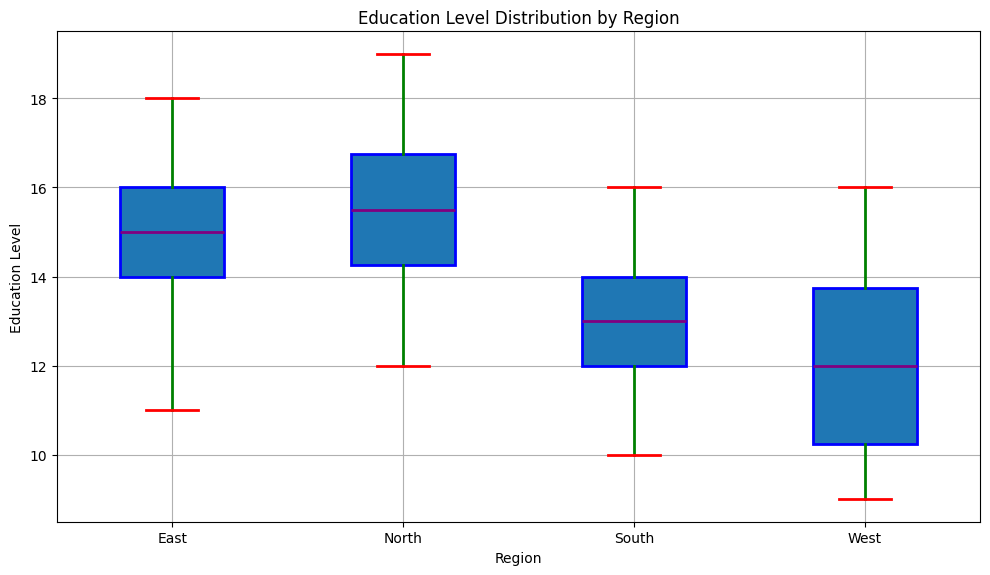What is the median education level in the North region? The median is the middle value in a sorted list. In the North region, the sorted education levels are 12, 13, 14, 15, 15, 16, 16, 17, 18, 19. The median value is between the 5th and 6th data points, which are both 15 and 16. So, the median is (15 + 16) / 2 = 15.5.
Answer: 15.5 Which region has the highest median education level? To determine this, we compare the medians from each region. From the figure, the medians are North: 15.5, South: 13, East: 15.5, West: 12.5. Both North and East have the highest median value of 15.5.
Answer: North and East What is the range of education levels in the South region? The range is the difference between the maximum and minimum values. From the box plot of the South region, the minimum is 10 and the maximum is 16. Therefore, the range is 16 - 10 = 6.
Answer: 6 Which region has the smallest interquartile range (IQR) of education levels? The IQR is the difference between the 75th percentile (Q3) and the 25th percentile (Q1). From the box plots, we visually inspect the length of the boxes (representing the IQR). The South region appears to have the smallest IQR.
Answer: South In which region is the variation in education levels the greatest? Variation refers to the spread of the data. Visually, this can be seen through the length of the whiskers and the spread of the outliers. The West region shows the greatest variation with the widest spread from 9 to 16.
Answer: West What is the maximum education level in the East region? The maximum value is represented by the top whisker or the highest outlier point. In the East region, the maximum education level is 18.
Answer: 18 Compare the median education levels between the South and the West regions. The median is found at the line inside the box. The South region has a median of 13, and the West region has a median of 12.5, so the South's median is higher.
Answer: South is higher How does the median education level in the North compare to the median in the East? Both the North and East regions have the same median education level, as indicated by the lines inside the boxes being at the same level, which is 15.5.
Answer: They are equal Which region has the most symmetric distribution of education levels? Symmetry can be assessed by the positions of the median line within the box and the lengths of the whiskers. The North region appears the most symmetric as the median is centrally located within the box, and the whiskers are of similar length.
Answer: North What is the interquartile range (IQR) of the East region? The IQR is calculated as Q3 (75th percentile) minus Q1 (25th percentile). For the East region, Q3 is approximately 16, and Q1 is approximately 14.5. Thus, the IQR is 16 - 14.5 = 1.5.
Answer: 1.5 